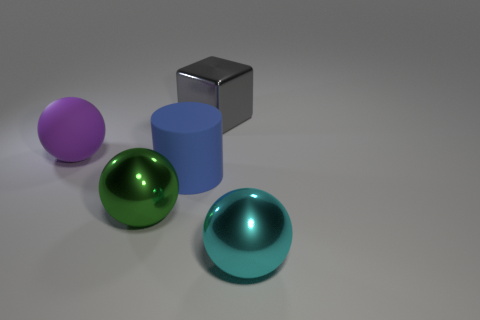Subtract all metallic balls. How many balls are left? 1 Add 2 purple matte spheres. How many objects exist? 7 Subtract all cylinders. How many objects are left? 4 Add 1 matte cylinders. How many matte cylinders exist? 2 Subtract 0 green cylinders. How many objects are left? 5 Subtract all large brown things. Subtract all green balls. How many objects are left? 4 Add 1 big blue matte cylinders. How many big blue matte cylinders are left? 2 